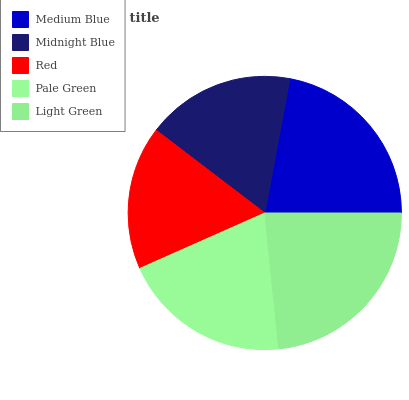Is Red the minimum?
Answer yes or no. Yes. Is Light Green the maximum?
Answer yes or no. Yes. Is Midnight Blue the minimum?
Answer yes or no. No. Is Midnight Blue the maximum?
Answer yes or no. No. Is Medium Blue greater than Midnight Blue?
Answer yes or no. Yes. Is Midnight Blue less than Medium Blue?
Answer yes or no. Yes. Is Midnight Blue greater than Medium Blue?
Answer yes or no. No. Is Medium Blue less than Midnight Blue?
Answer yes or no. No. Is Pale Green the high median?
Answer yes or no. Yes. Is Pale Green the low median?
Answer yes or no. Yes. Is Midnight Blue the high median?
Answer yes or no. No. Is Medium Blue the low median?
Answer yes or no. No. 